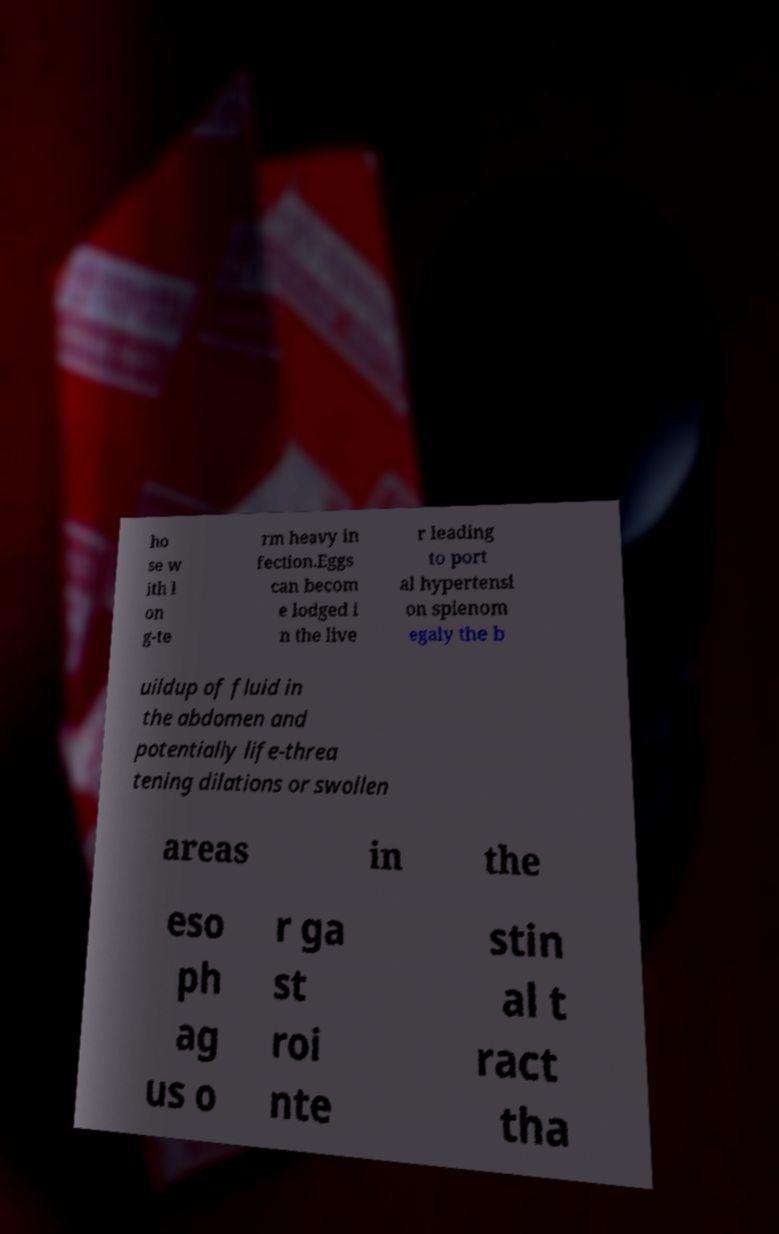What messages or text are displayed in this image? I need them in a readable, typed format. ho se w ith l on g-te rm heavy in fection.Eggs can becom e lodged i n the live r leading to port al hypertensi on splenom egaly the b uildup of fluid in the abdomen and potentially life-threa tening dilations or swollen areas in the eso ph ag us o r ga st roi nte stin al t ract tha 